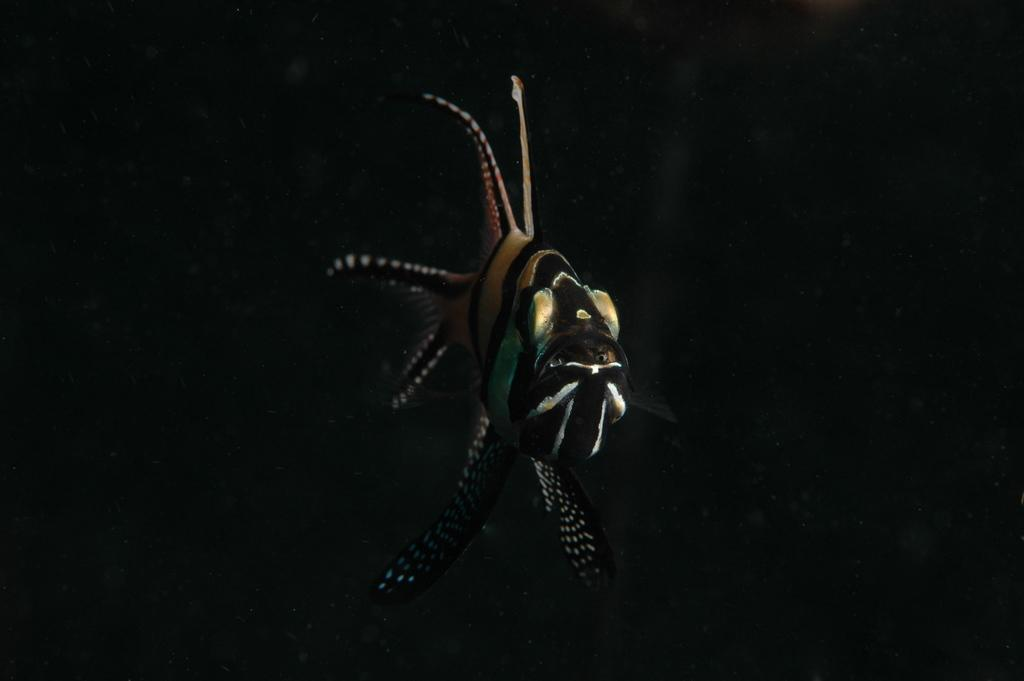What is the main subject of the image? There is a fish in the image. Where is the fish located? The fish is in water. What color is the background of the image? The background of the image is black. Can you see a grape in the image? There is no grape present in the image. Is the fish wearing a veil in the image? Fish do not wear veils, and there is no indication of any clothing or accessories on the fish in the image. 